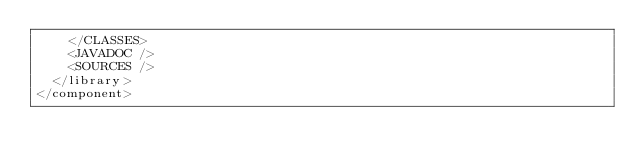<code> <loc_0><loc_0><loc_500><loc_500><_XML_>    </CLASSES>
    <JAVADOC />
    <SOURCES />
  </library>
</component></code> 